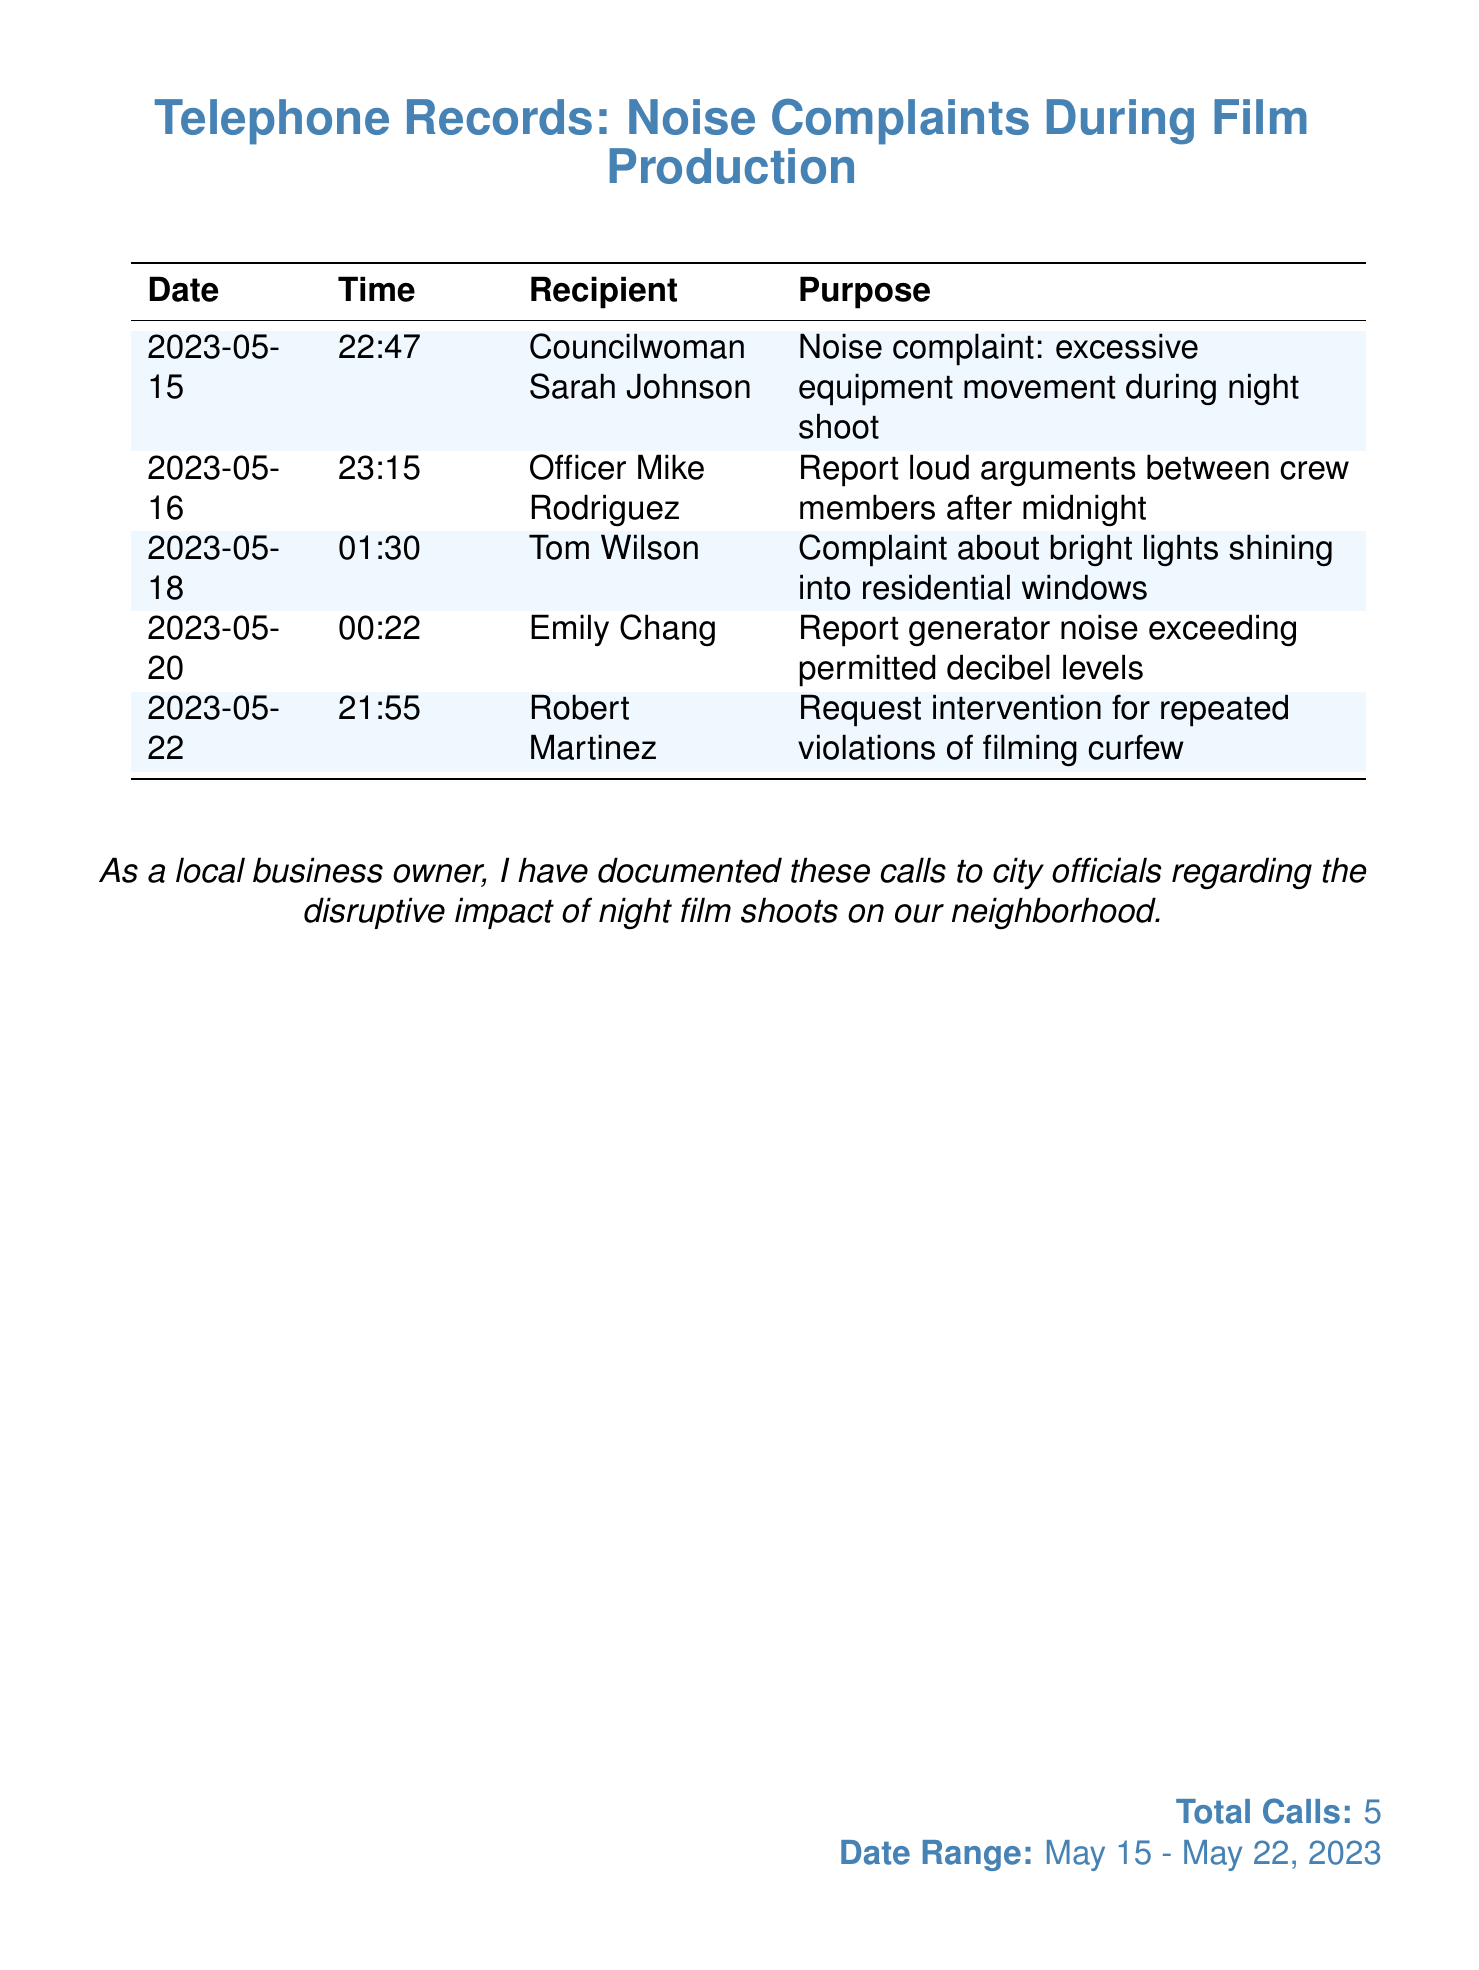What is the date of the first recorded call? The first recorded call took place on May 15, 2023.
Answer: May 15, 2023 Who did the caller report excessive equipment movement to? The caller reported excessive equipment movement to Councilwoman Sarah Johnson.
Answer: Councilwoman Sarah Johnson What time was the noise complaint about generator noise made? The noise complaint about generator noise was made at 00:22.
Answer: 00:22 How many calls were made in total? The total number of calls documented is stated clearly at the bottom of the document.
Answer: 5 What was the purpose of the call made on May 22? The purpose of the call made on May 22 was to request intervention for repeated violations of filming curfew.
Answer: Request intervention for repeated violations of filming curfew Which city official received a complaint about bright lights shining into residential windows? The complaint about bright lights shining into residential windows was made to Tom Wilson.
Answer: Tom Wilson What was reported during the call to Officer Mike Rodriguez? The report during the call to Officer Mike Rodriguez was about loud arguments between crew members after midnight.
Answer: Loud arguments between crew members after midnight What was the date range of the recorded calls? The date range of the recorded calls is provided at the bottom as the span between May 15 and May 22, 2023.
Answer: May 15 - May 22, 2023 